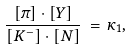<formula> <loc_0><loc_0><loc_500><loc_500>\frac { [ \pi ] \cdot [ Y ] } { [ K ^ { - } ] \cdot [ N ] } \, = \, \kappa _ { 1 } ,</formula> 